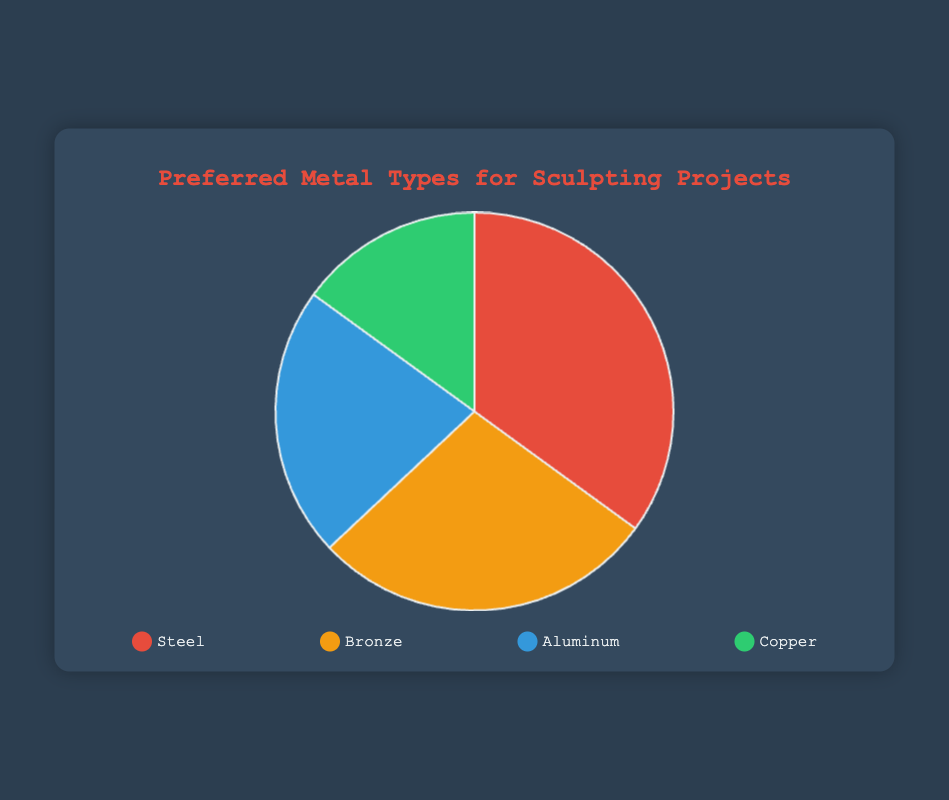What percentage of art students prefer Steel for sculpting? Look at the Pie chart and find the section labeled "Steel". The percentage for Steel is provided directly on the chart.
Answer: 35% Which metal is the least preferred among art students for sculpting projects? Identify the smallest section of the Pie chart. The section representing Copper is the smallest.
Answer: Copper How much more popular is Steel compared to Copper? Find the percentages for Steel and Copper from the Pie chart. Subtract Copper's percentage from Steel's percentage: 35% - 15% = 20%
Answer: 20% Which metal types together constitute more than half of the preferences among art students? Sum the percentages of different metals and check if the total exceeds 50%. Steel (35%) and Bronze (28%) together give 35% + 28% = 63%. This sum is more than 50%.
Answer: Steel and Bronze What is the combined percentage preference for Aluminum and Copper? Add the percentages for Aluminum and Copper from the Pie chart: 22% + 15% = 37%
Answer: 37% Which metal has a higher preference, Aluminum or Bronze, and by how much? Compare the percentages for Aluminum and Bronze from the Pie chart: Bronze (28%) and Aluminum (22%). Subtract Aluminum's percentage from Bronze's: 28% - 22% = 6%
Answer: Bronze by 6% What is the average percentage preference for all four metals? Add the percentages for all four metals and divide by the number of metals: (35% + 28% + 22% + 15%) / 4 = 100% / 4 = 25%
Answer: 25% Which section of the Pie chart is colored blue and what does it represent? Identify the section of the Pie chart that is blue. The blue section represents Aluminum.
Answer: Aluminum Which two metals combined have a similar percentage preference to Steel? Find two metals whose combined percentages are close to Steel's percentage. Aluminum (22%) and Copper (15%) together make up 22% + 15% = 37%, which is closest to Steel's 35%.
Answer: Aluminum and Copper How does the preference for traditional materials (Bronze and Copper) compare to modern materials (Steel and Aluminum)? Sum the percentages for Bronze and Copper, then for Steel and Aluminum: Bronze (28%) + Copper (15%) = 43%, Steel (35%) + Aluminum (22%) = 57%. Compare the two sums.
Answer: Modern materials are preferred by 14% more 